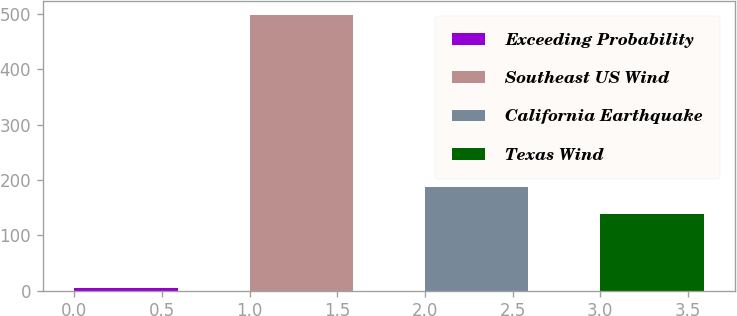Convert chart. <chart><loc_0><loc_0><loc_500><loc_500><bar_chart><fcel>Exceeding Probability<fcel>Southeast US Wind<fcel>California Earthquake<fcel>Texas Wind<nl><fcel>5<fcel>499<fcel>187.4<fcel>138<nl></chart> 